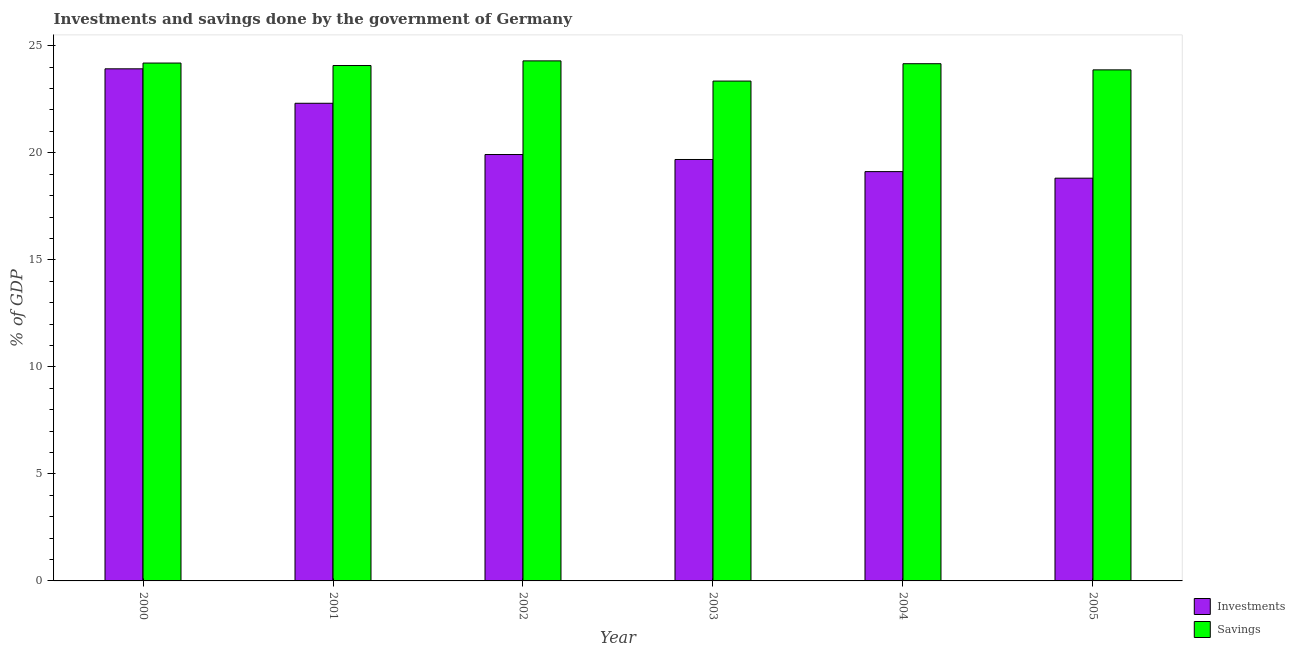How many groups of bars are there?
Provide a short and direct response. 6. How many bars are there on the 4th tick from the right?
Make the answer very short. 2. What is the savings of government in 2001?
Make the answer very short. 24.08. Across all years, what is the maximum investments of government?
Give a very brief answer. 23.92. Across all years, what is the minimum investments of government?
Offer a very short reply. 18.81. What is the total investments of government in the graph?
Offer a terse response. 123.78. What is the difference between the investments of government in 2001 and that in 2002?
Offer a very short reply. 2.39. What is the difference between the savings of government in 2001 and the investments of government in 2000?
Give a very brief answer. -0.11. What is the average savings of government per year?
Provide a succinct answer. 23.99. In how many years, is the savings of government greater than 8 %?
Give a very brief answer. 6. What is the ratio of the investments of government in 2000 to that in 2003?
Offer a very short reply. 1.22. What is the difference between the highest and the second highest savings of government?
Your response must be concise. 0.1. What is the difference between the highest and the lowest savings of government?
Offer a terse response. 0.94. What does the 1st bar from the left in 2004 represents?
Offer a terse response. Investments. What does the 1st bar from the right in 2005 represents?
Offer a terse response. Savings. How many bars are there?
Your answer should be compact. 12. Are all the bars in the graph horizontal?
Your response must be concise. No. What is the difference between two consecutive major ticks on the Y-axis?
Give a very brief answer. 5. Are the values on the major ticks of Y-axis written in scientific E-notation?
Make the answer very short. No. How are the legend labels stacked?
Your answer should be very brief. Vertical. What is the title of the graph?
Offer a very short reply. Investments and savings done by the government of Germany. Does "Electricity and heat production" appear as one of the legend labels in the graph?
Offer a very short reply. No. What is the label or title of the X-axis?
Your response must be concise. Year. What is the label or title of the Y-axis?
Give a very brief answer. % of GDP. What is the % of GDP in Investments in 2000?
Make the answer very short. 23.92. What is the % of GDP of Savings in 2000?
Provide a short and direct response. 24.19. What is the % of GDP of Investments in 2001?
Provide a succinct answer. 22.31. What is the % of GDP of Savings in 2001?
Provide a short and direct response. 24.08. What is the % of GDP of Investments in 2002?
Your answer should be very brief. 19.92. What is the % of GDP in Savings in 2002?
Offer a very short reply. 24.29. What is the % of GDP of Investments in 2003?
Offer a terse response. 19.69. What is the % of GDP of Savings in 2003?
Your answer should be compact. 23.35. What is the % of GDP of Investments in 2004?
Offer a very short reply. 19.12. What is the % of GDP in Savings in 2004?
Provide a succinct answer. 24.16. What is the % of GDP of Investments in 2005?
Your answer should be compact. 18.81. What is the % of GDP of Savings in 2005?
Your answer should be compact. 23.87. Across all years, what is the maximum % of GDP in Investments?
Offer a terse response. 23.92. Across all years, what is the maximum % of GDP of Savings?
Provide a short and direct response. 24.29. Across all years, what is the minimum % of GDP of Investments?
Give a very brief answer. 18.81. Across all years, what is the minimum % of GDP in Savings?
Provide a short and direct response. 23.35. What is the total % of GDP in Investments in the graph?
Your response must be concise. 123.78. What is the total % of GDP in Savings in the graph?
Your answer should be very brief. 143.95. What is the difference between the % of GDP in Investments in 2000 and that in 2001?
Ensure brevity in your answer.  1.61. What is the difference between the % of GDP of Savings in 2000 and that in 2001?
Keep it short and to the point. 0.11. What is the difference between the % of GDP of Investments in 2000 and that in 2002?
Provide a succinct answer. 4. What is the difference between the % of GDP of Savings in 2000 and that in 2002?
Give a very brief answer. -0.1. What is the difference between the % of GDP in Investments in 2000 and that in 2003?
Give a very brief answer. 4.24. What is the difference between the % of GDP of Savings in 2000 and that in 2003?
Your answer should be very brief. 0.84. What is the difference between the % of GDP in Investments in 2000 and that in 2004?
Give a very brief answer. 4.8. What is the difference between the % of GDP of Savings in 2000 and that in 2004?
Provide a short and direct response. 0.03. What is the difference between the % of GDP of Investments in 2000 and that in 2005?
Your answer should be very brief. 5.11. What is the difference between the % of GDP of Savings in 2000 and that in 2005?
Make the answer very short. 0.32. What is the difference between the % of GDP of Investments in 2001 and that in 2002?
Make the answer very short. 2.39. What is the difference between the % of GDP of Savings in 2001 and that in 2002?
Your response must be concise. -0.22. What is the difference between the % of GDP in Investments in 2001 and that in 2003?
Your answer should be very brief. 2.63. What is the difference between the % of GDP of Savings in 2001 and that in 2003?
Your response must be concise. 0.73. What is the difference between the % of GDP in Investments in 2001 and that in 2004?
Offer a very short reply. 3.19. What is the difference between the % of GDP of Savings in 2001 and that in 2004?
Your answer should be very brief. -0.08. What is the difference between the % of GDP in Investments in 2001 and that in 2005?
Keep it short and to the point. 3.5. What is the difference between the % of GDP in Savings in 2001 and that in 2005?
Ensure brevity in your answer.  0.2. What is the difference between the % of GDP of Investments in 2002 and that in 2003?
Offer a very short reply. 0.23. What is the difference between the % of GDP in Savings in 2002 and that in 2003?
Your response must be concise. 0.94. What is the difference between the % of GDP in Investments in 2002 and that in 2004?
Your answer should be very brief. 0.8. What is the difference between the % of GDP in Savings in 2002 and that in 2004?
Make the answer very short. 0.13. What is the difference between the % of GDP of Investments in 2002 and that in 2005?
Ensure brevity in your answer.  1.1. What is the difference between the % of GDP in Savings in 2002 and that in 2005?
Your answer should be compact. 0.42. What is the difference between the % of GDP of Investments in 2003 and that in 2004?
Give a very brief answer. 0.57. What is the difference between the % of GDP in Savings in 2003 and that in 2004?
Offer a terse response. -0.81. What is the difference between the % of GDP in Investments in 2003 and that in 2005?
Give a very brief answer. 0.87. What is the difference between the % of GDP of Savings in 2003 and that in 2005?
Provide a succinct answer. -0.52. What is the difference between the % of GDP in Investments in 2004 and that in 2005?
Offer a terse response. 0.31. What is the difference between the % of GDP of Savings in 2004 and that in 2005?
Keep it short and to the point. 0.29. What is the difference between the % of GDP in Investments in 2000 and the % of GDP in Savings in 2001?
Keep it short and to the point. -0.15. What is the difference between the % of GDP of Investments in 2000 and the % of GDP of Savings in 2002?
Your answer should be very brief. -0.37. What is the difference between the % of GDP in Investments in 2000 and the % of GDP in Savings in 2003?
Provide a short and direct response. 0.57. What is the difference between the % of GDP in Investments in 2000 and the % of GDP in Savings in 2004?
Provide a succinct answer. -0.24. What is the difference between the % of GDP in Investments in 2000 and the % of GDP in Savings in 2005?
Keep it short and to the point. 0.05. What is the difference between the % of GDP in Investments in 2001 and the % of GDP in Savings in 2002?
Give a very brief answer. -1.98. What is the difference between the % of GDP in Investments in 2001 and the % of GDP in Savings in 2003?
Provide a short and direct response. -1.04. What is the difference between the % of GDP of Investments in 2001 and the % of GDP of Savings in 2004?
Your answer should be compact. -1.85. What is the difference between the % of GDP in Investments in 2001 and the % of GDP in Savings in 2005?
Offer a very short reply. -1.56. What is the difference between the % of GDP of Investments in 2002 and the % of GDP of Savings in 2003?
Offer a very short reply. -3.43. What is the difference between the % of GDP in Investments in 2002 and the % of GDP in Savings in 2004?
Your response must be concise. -4.24. What is the difference between the % of GDP in Investments in 2002 and the % of GDP in Savings in 2005?
Offer a terse response. -3.96. What is the difference between the % of GDP of Investments in 2003 and the % of GDP of Savings in 2004?
Your answer should be very brief. -4.47. What is the difference between the % of GDP of Investments in 2003 and the % of GDP of Savings in 2005?
Provide a short and direct response. -4.19. What is the difference between the % of GDP of Investments in 2004 and the % of GDP of Savings in 2005?
Your answer should be very brief. -4.75. What is the average % of GDP in Investments per year?
Keep it short and to the point. 20.63. What is the average % of GDP of Savings per year?
Provide a short and direct response. 23.99. In the year 2000, what is the difference between the % of GDP of Investments and % of GDP of Savings?
Keep it short and to the point. -0.27. In the year 2001, what is the difference between the % of GDP in Investments and % of GDP in Savings?
Provide a succinct answer. -1.76. In the year 2002, what is the difference between the % of GDP of Investments and % of GDP of Savings?
Provide a succinct answer. -4.38. In the year 2003, what is the difference between the % of GDP in Investments and % of GDP in Savings?
Keep it short and to the point. -3.66. In the year 2004, what is the difference between the % of GDP in Investments and % of GDP in Savings?
Provide a succinct answer. -5.04. In the year 2005, what is the difference between the % of GDP of Investments and % of GDP of Savings?
Your answer should be compact. -5.06. What is the ratio of the % of GDP in Investments in 2000 to that in 2001?
Make the answer very short. 1.07. What is the ratio of the % of GDP of Savings in 2000 to that in 2001?
Offer a terse response. 1. What is the ratio of the % of GDP of Investments in 2000 to that in 2002?
Ensure brevity in your answer.  1.2. What is the ratio of the % of GDP in Savings in 2000 to that in 2002?
Offer a terse response. 1. What is the ratio of the % of GDP in Investments in 2000 to that in 2003?
Offer a very short reply. 1.22. What is the ratio of the % of GDP of Savings in 2000 to that in 2003?
Offer a terse response. 1.04. What is the ratio of the % of GDP of Investments in 2000 to that in 2004?
Provide a succinct answer. 1.25. What is the ratio of the % of GDP of Savings in 2000 to that in 2004?
Offer a terse response. 1. What is the ratio of the % of GDP in Investments in 2000 to that in 2005?
Your response must be concise. 1.27. What is the ratio of the % of GDP in Savings in 2000 to that in 2005?
Offer a terse response. 1.01. What is the ratio of the % of GDP of Investments in 2001 to that in 2002?
Keep it short and to the point. 1.12. What is the ratio of the % of GDP in Investments in 2001 to that in 2003?
Make the answer very short. 1.13. What is the ratio of the % of GDP in Savings in 2001 to that in 2003?
Your answer should be compact. 1.03. What is the ratio of the % of GDP of Investments in 2001 to that in 2004?
Make the answer very short. 1.17. What is the ratio of the % of GDP of Savings in 2001 to that in 2004?
Your answer should be very brief. 1. What is the ratio of the % of GDP of Investments in 2001 to that in 2005?
Your response must be concise. 1.19. What is the ratio of the % of GDP in Savings in 2001 to that in 2005?
Your answer should be very brief. 1.01. What is the ratio of the % of GDP of Investments in 2002 to that in 2003?
Provide a short and direct response. 1.01. What is the ratio of the % of GDP in Savings in 2002 to that in 2003?
Make the answer very short. 1.04. What is the ratio of the % of GDP in Investments in 2002 to that in 2004?
Your response must be concise. 1.04. What is the ratio of the % of GDP in Investments in 2002 to that in 2005?
Keep it short and to the point. 1.06. What is the ratio of the % of GDP in Savings in 2002 to that in 2005?
Keep it short and to the point. 1.02. What is the ratio of the % of GDP of Investments in 2003 to that in 2004?
Ensure brevity in your answer.  1.03. What is the ratio of the % of GDP of Savings in 2003 to that in 2004?
Give a very brief answer. 0.97. What is the ratio of the % of GDP of Investments in 2003 to that in 2005?
Offer a very short reply. 1.05. What is the ratio of the % of GDP in Savings in 2003 to that in 2005?
Provide a succinct answer. 0.98. What is the ratio of the % of GDP in Investments in 2004 to that in 2005?
Ensure brevity in your answer.  1.02. What is the difference between the highest and the second highest % of GDP in Investments?
Provide a succinct answer. 1.61. What is the difference between the highest and the second highest % of GDP of Savings?
Offer a terse response. 0.1. What is the difference between the highest and the lowest % of GDP in Investments?
Keep it short and to the point. 5.11. What is the difference between the highest and the lowest % of GDP of Savings?
Keep it short and to the point. 0.94. 